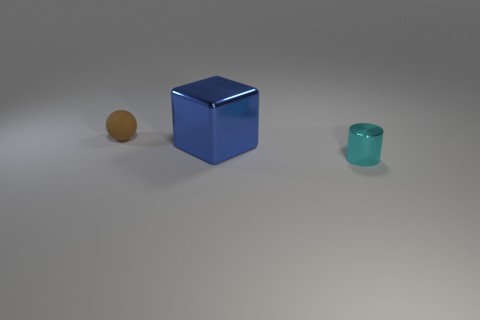Add 3 blue metallic things. How many objects exist? 6 Subtract 1 cylinders. How many cylinders are left? 0 Subtract all cylinders. How many objects are left? 2 Subtract 1 cyan cylinders. How many objects are left? 2 Subtract all purple balls. Subtract all blue cylinders. How many balls are left? 1 Subtract all big cyan cubes. Subtract all tiny brown balls. How many objects are left? 2 Add 3 big blue things. How many big blue things are left? 4 Add 2 small red shiny balls. How many small red shiny balls exist? 2 